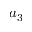Convert formula to latex. <formula><loc_0><loc_0><loc_500><loc_500>a _ { 3 }</formula> 